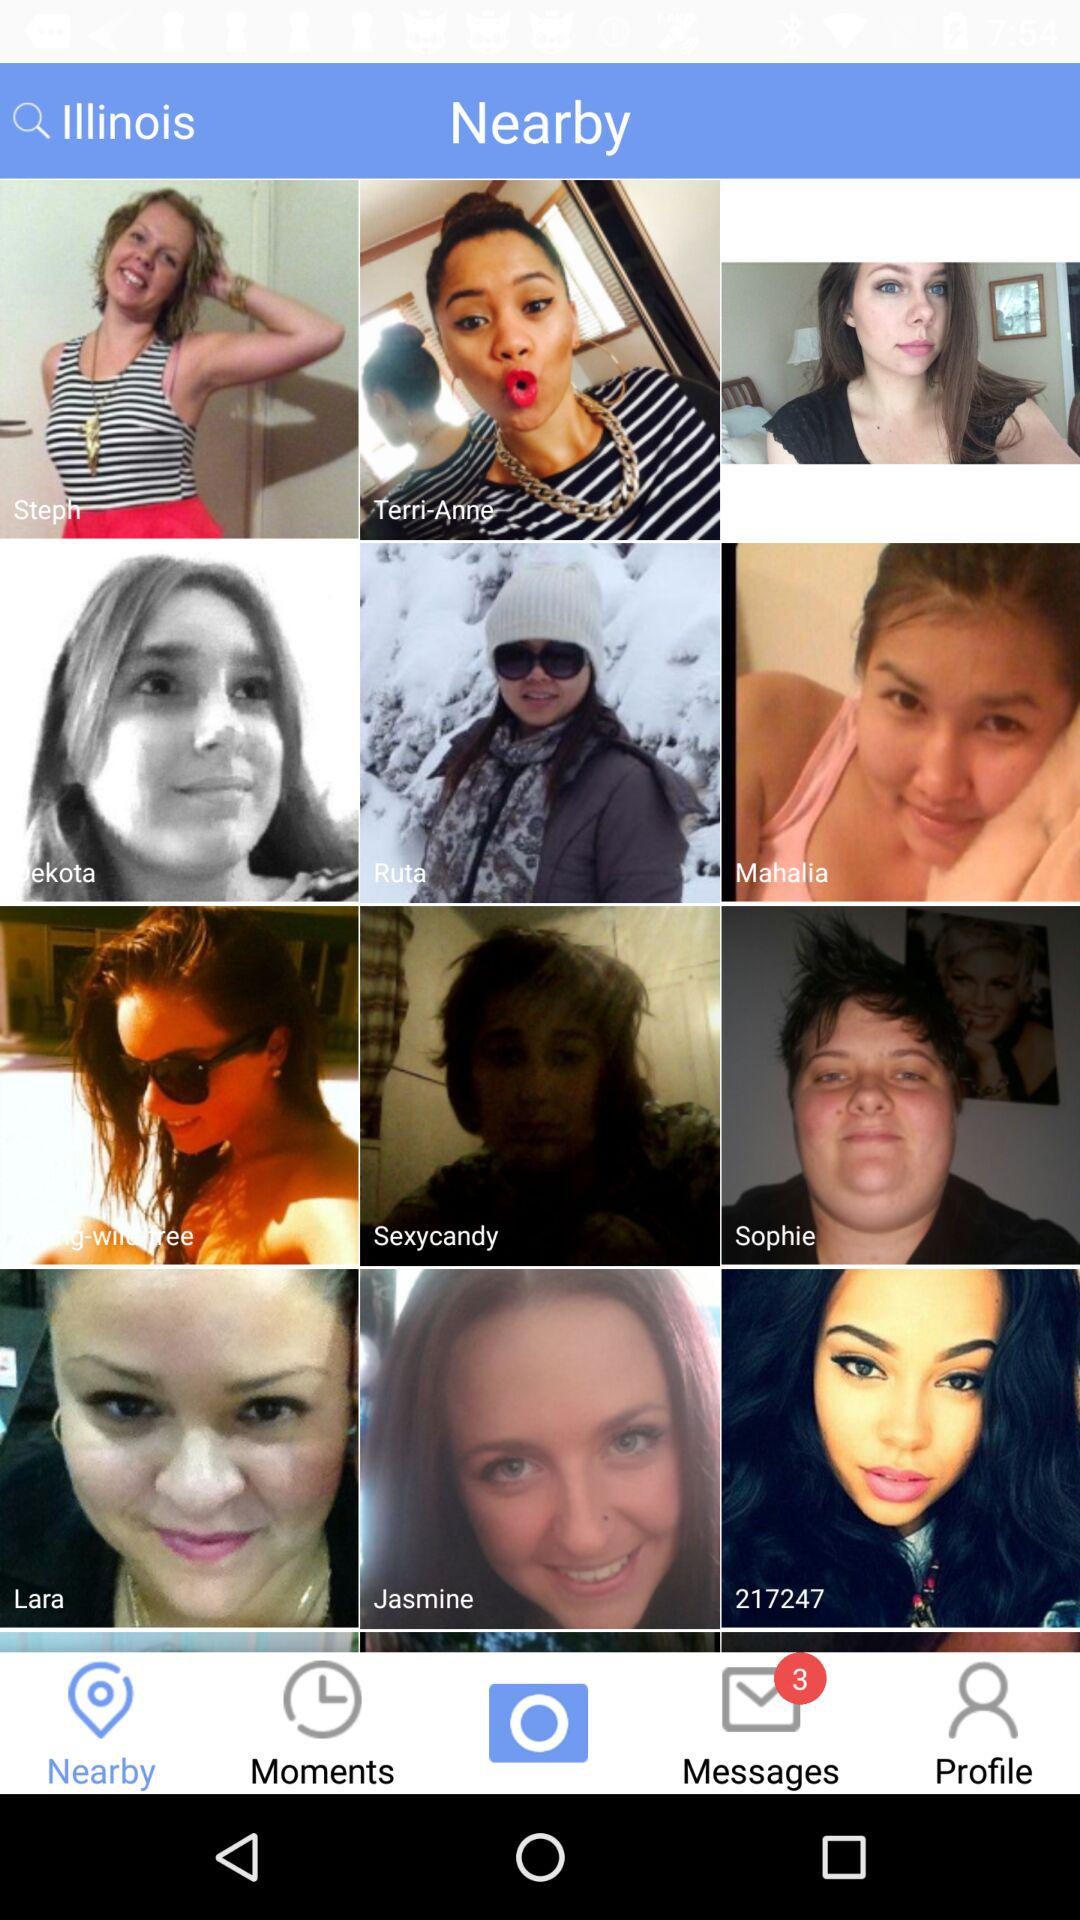Which tab is selected? The selected tab is "Nearby". 